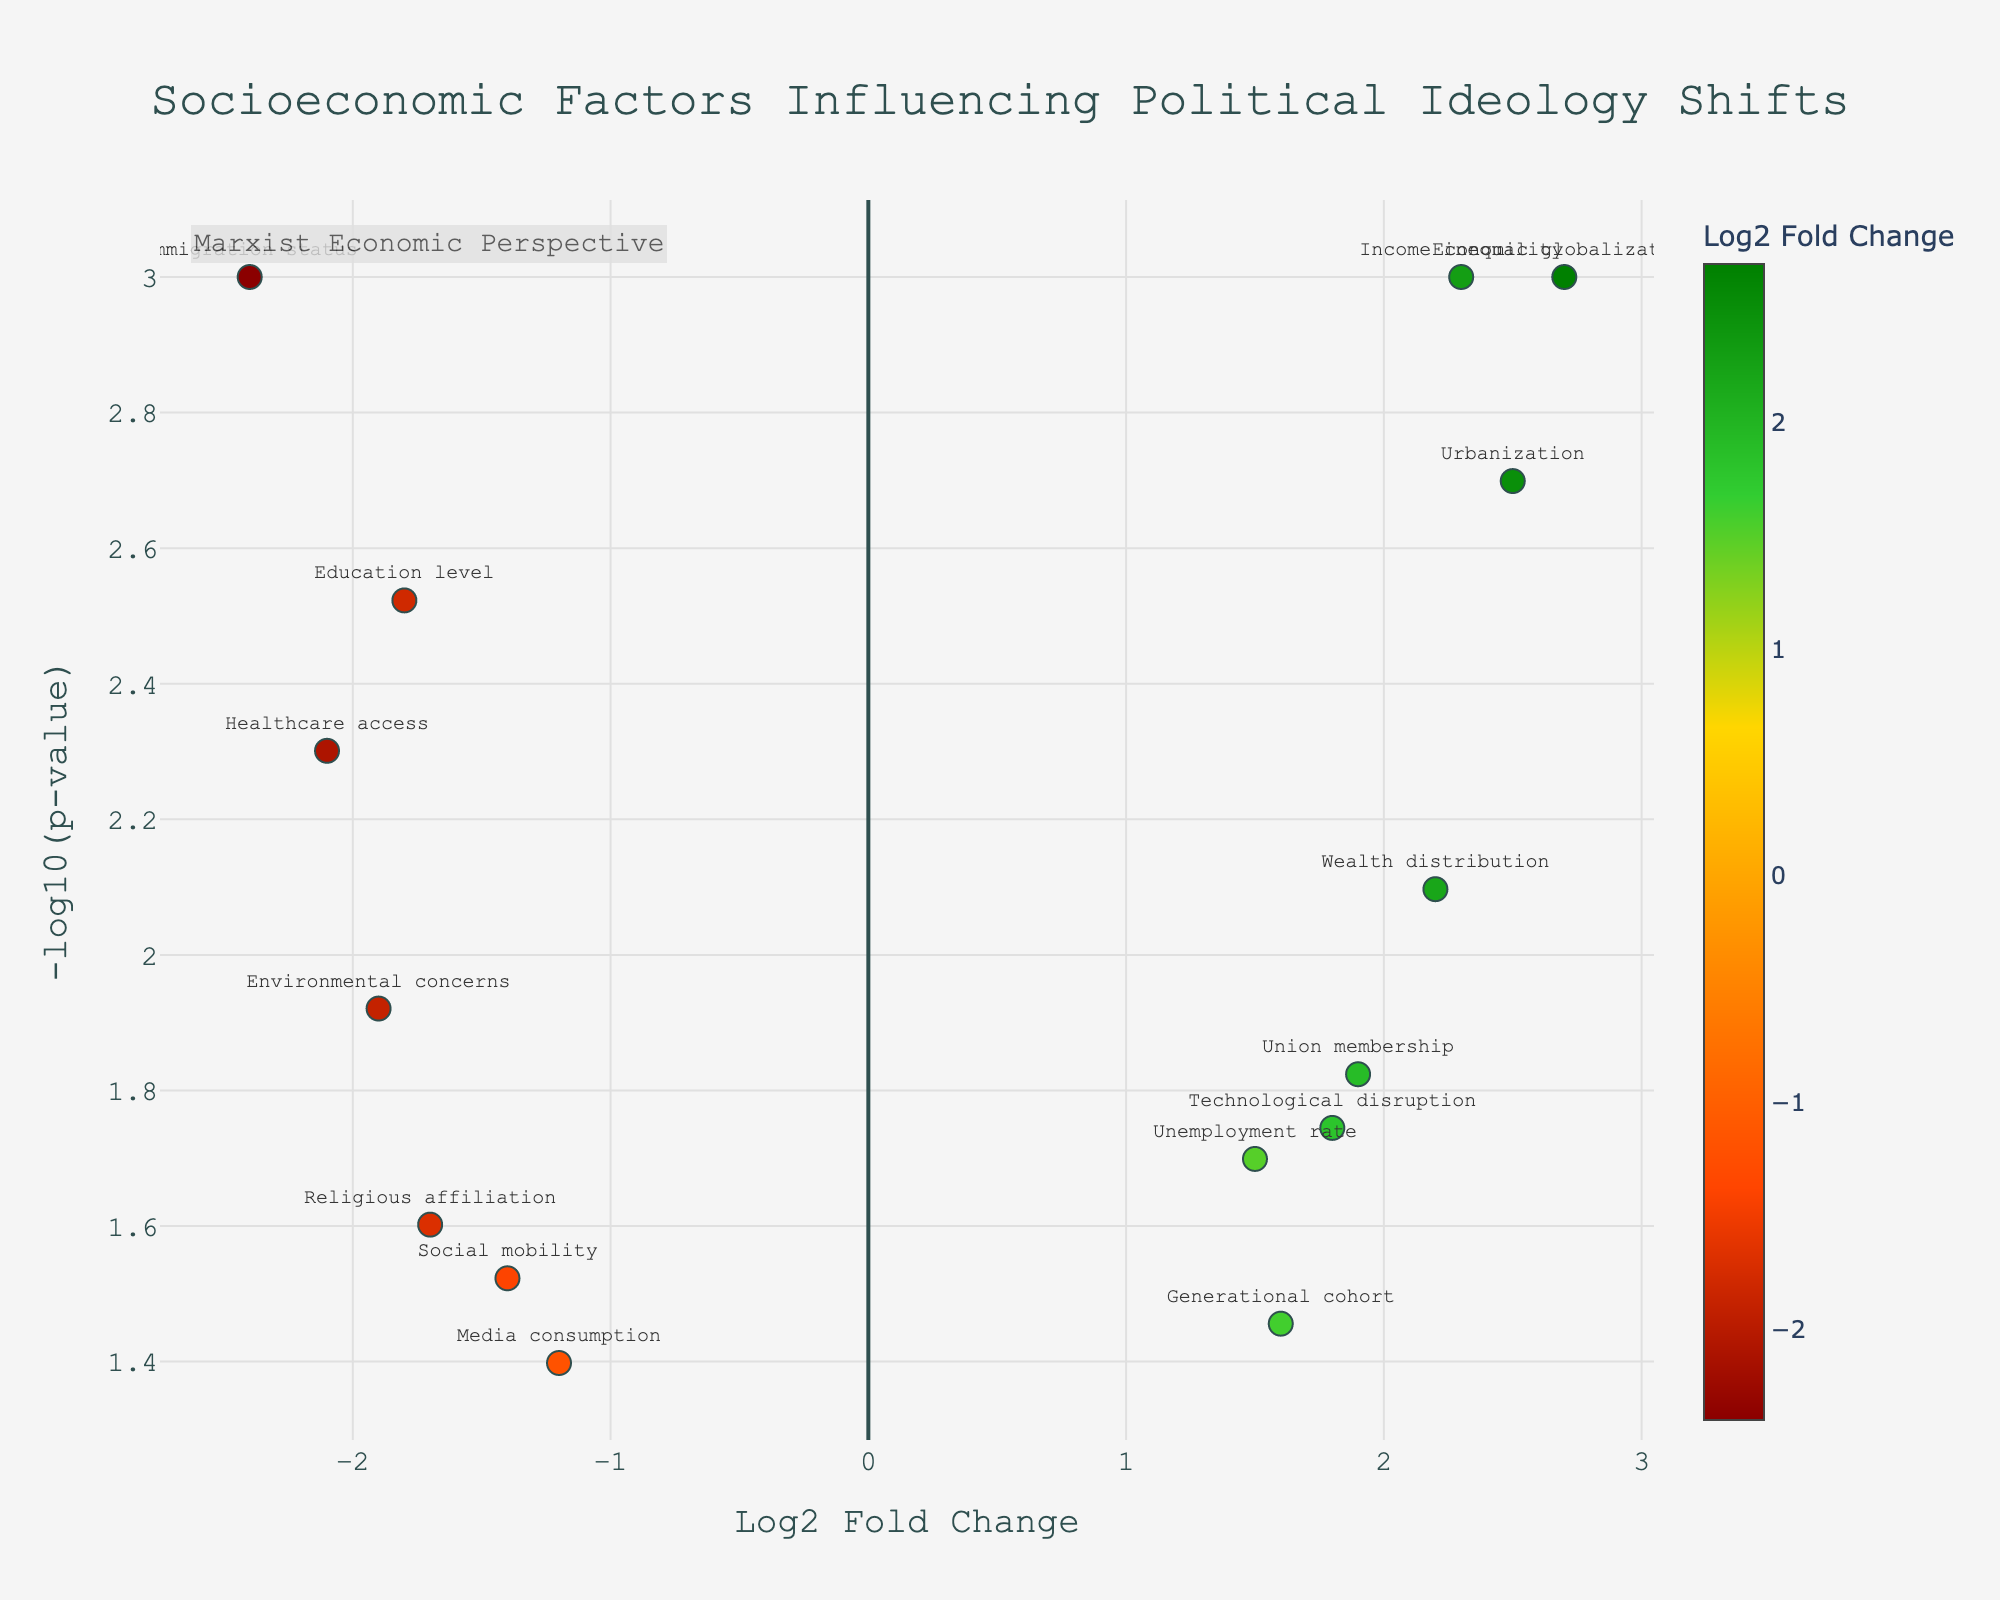What is the full title of the plot? The title is centered at the top of the plot and reads "Socioeconomic Factors Influencing Political Ideology Shifts."
Answer: Socioeconomic Factors Influencing Political Ideology Shifts Which factor has the highest log2 fold change and what is its value? The point with the highest log2 fold change is labeled "Economic globalization," positioned around log2 fold change of 2.7.
Answer: Economic globalization, 2.7 Which factor has the lowest p-value and what is its -log10(p-value)? The point with the lowest p-value is "Economic globalization" as it is closest to the y-axis maximum, with -log10(p-value) around 3 (indicating p-value of 0.001).
Answer: Economic globalization, 3 How many factors have a p-value less than 0.01? Points with a minimum -log10(p-value) of 2 (since -log10(0.01) = 2) should be counted. Factors are "Income inequality," "Immigration status," "Urbanization," "Healthcare access," and "Wealth distribution."
Answer: 5 Which factors have a negative log2 fold change and what are their names? Factors with points positioned to the left of the vertical line (log2 fold change < 0) are "Education level," "Healthcare access," "Media consumption," "Religious affiliation," "Immigration status," "Social mobility," and "Environmental concerns."
Answer: Education level, Healthcare access, Media consumption, Religious affiliation, Immigration status, Social mobility, Environmental concerns Which factor has the smallest absolute log2 fold change? The point closest to the vertical line (log2 fold change = 0) is labeled "Media consumption," with an absolute log2 fold change around 1.2.
Answer: Media consumption What is the range of -log10(p-value) covered in the figure? The range extends from the lowest visible -log10(p-value) just above 1.3 (log2 fold change ~1.2 or -1.4) to the highest around 3 (log2 fold change ~2.7).
Answer: 1.3 to 3 Compare the p-value and log2 fold change for "Union membership" and "Technological disruption." Which has a higher fold change, and which has a lower p-value? "Union membership" has a higher log2 fold change (~1.9) than "Technological disruption" (~1.8), but "Union membership" also has a slightly lower p-value (indicated by higher -log10(p-value)).
Answer: Union membership (both) Which color represents the highest log2 fold changes in the plot? Refer to the color scale where the highest values are in green (#008000).
Answer: Green Which factors cluster together at the higher log2 fold changes and -log10(p-values)? Factors in the top-right region with both high log2 fold changes and low p-values: "Economic globalization," "Income inequality," "Urbanization," "Union membership."
Answer: Economic globalization, Income inequality, Urbanization, Union membership 